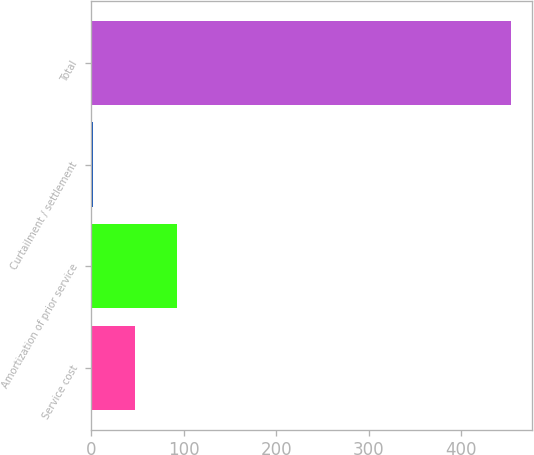Convert chart to OTSL. <chart><loc_0><loc_0><loc_500><loc_500><bar_chart><fcel>Service cost<fcel>Amortization of prior service<fcel>Curtailment / settlement<fcel>Total<nl><fcel>47.2<fcel>92.4<fcel>2<fcel>454<nl></chart> 